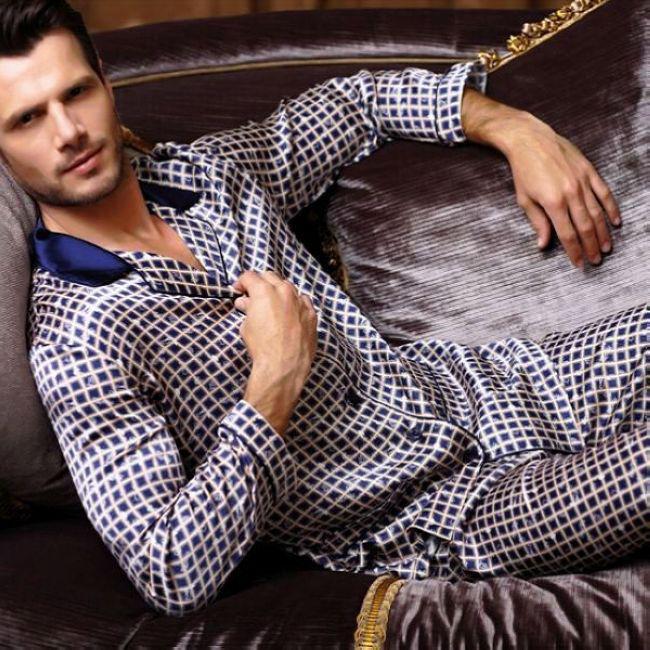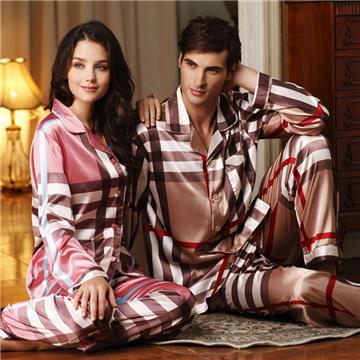The first image is the image on the left, the second image is the image on the right. Assess this claim about the two images: "the man is holding something in his hands in the right pic". Correct or not? Answer yes or no. No. The first image is the image on the left, the second image is the image on the right. Examine the images to the left and right. Is the description "In one of the images, a man is wearing checkered pajamas." accurate? Answer yes or no. Yes. 